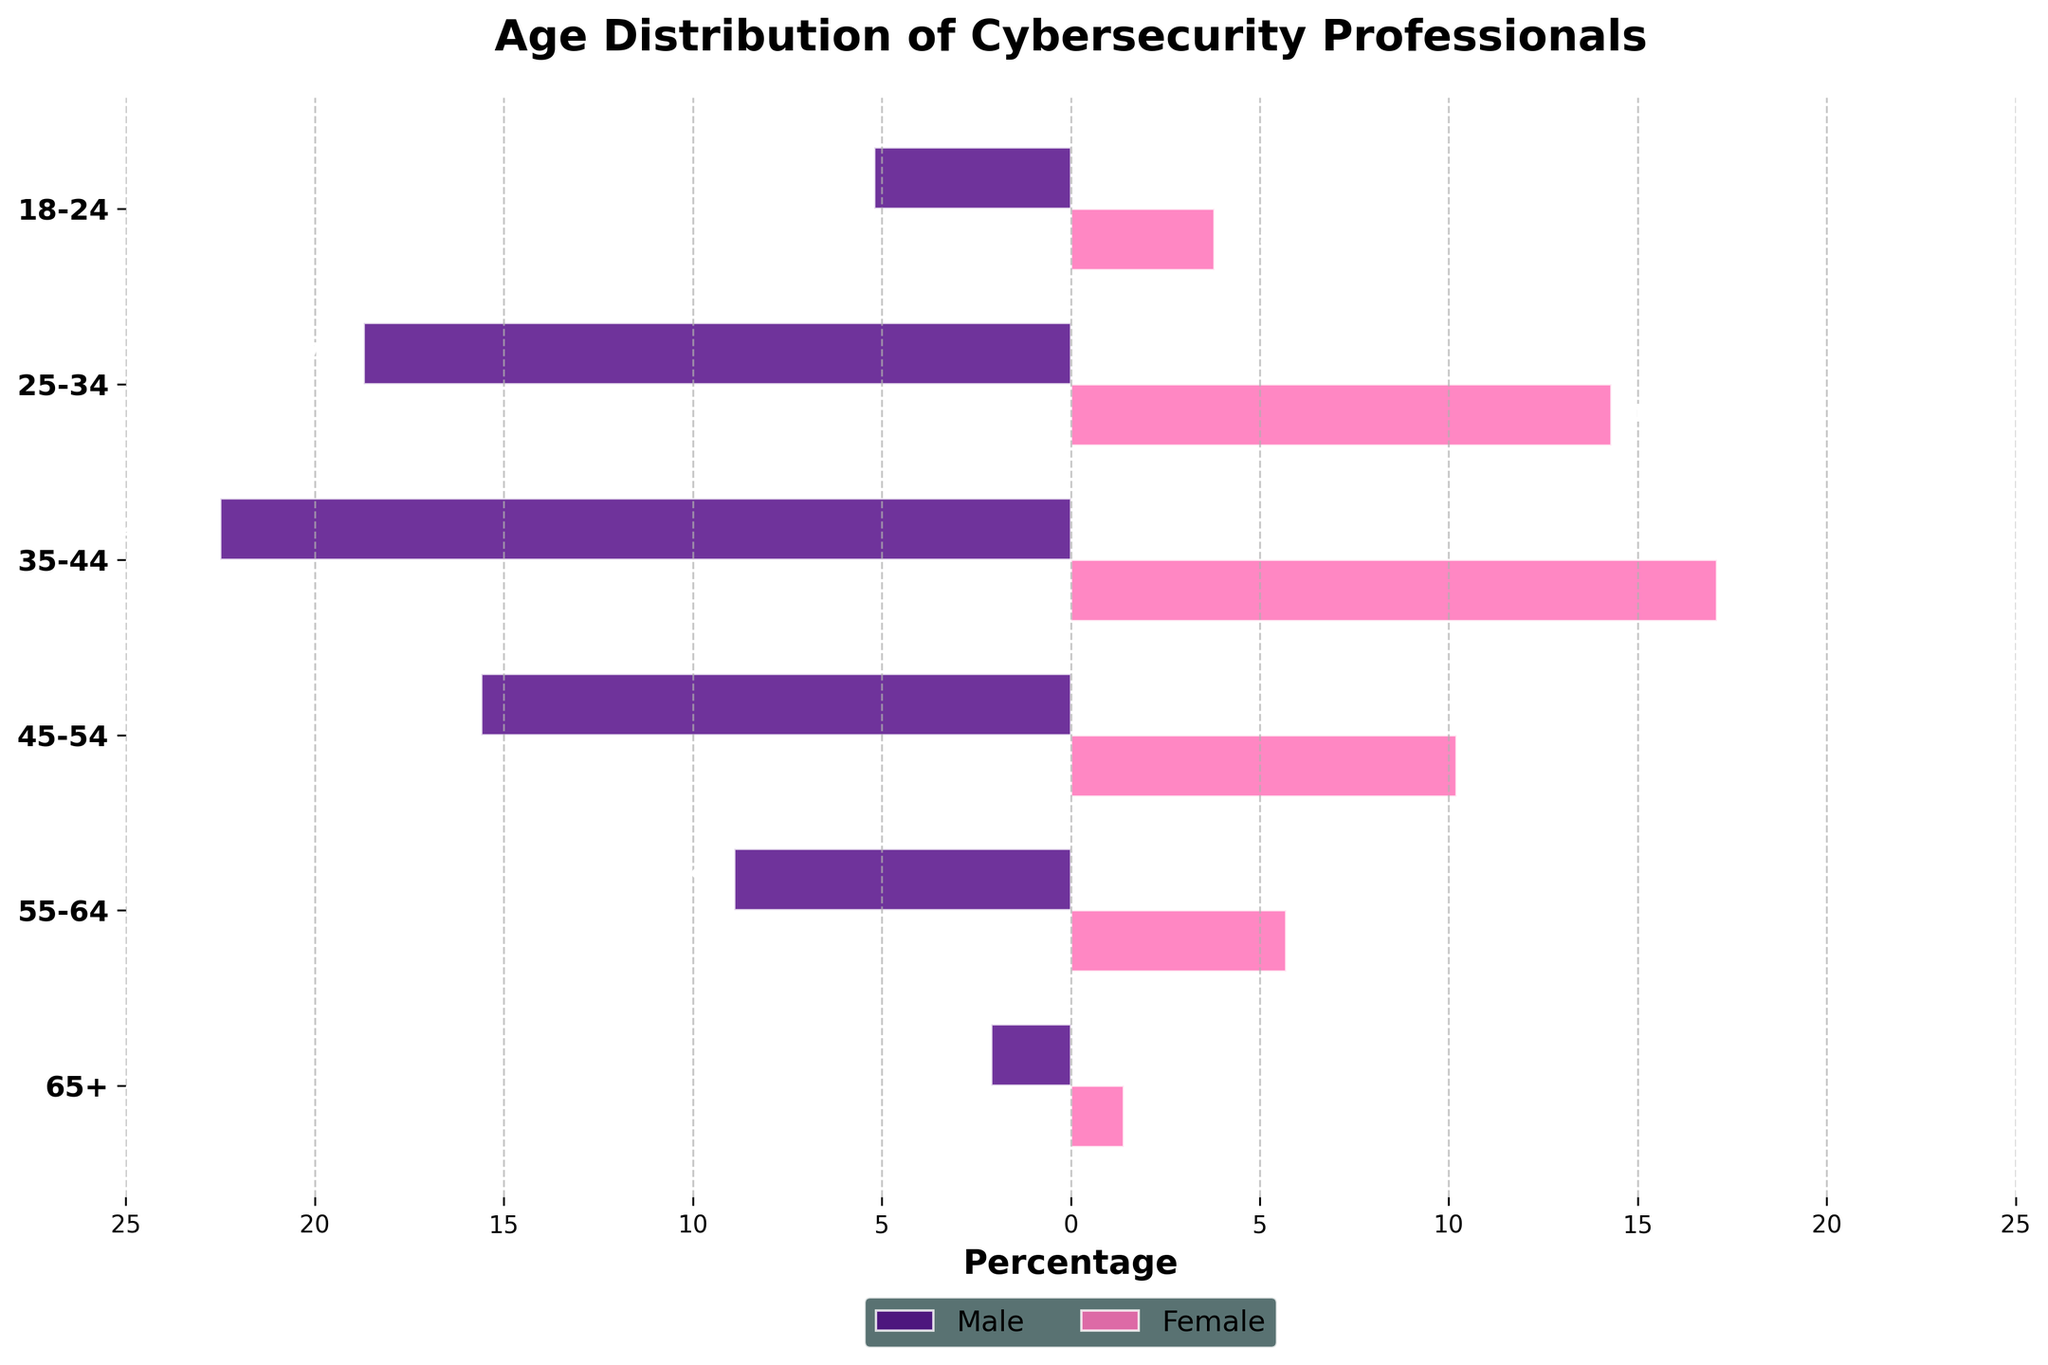What is the title of the figure? The title of the figure is usually placed at the top of the chart. In this case, it is explicitly stated in the plot design.
Answer: 'Age Distribution of Cybersecurity Professionals' What are the color codes used to represent male and female professionals? By observing the colors highlighted in the bars, we can identify Purple for males and Pink for females.
Answer: Males are in Purple; Females are in Pink Which age group has the largest percentage of male professionals? Looking at the lengths of the purple bars representing males, the age group 35-44 has the longest bar.
Answer: 35-44 age group Which age group has the smallest percentage of female professionals? By comparing the lengths of the pink bars across age groups, we see that the 65+ group has the shortest bar.
Answer: 65+ age group What is the percentage difference between males and females in the 25-34 age group? The values are 18.7% for males and 14.3% for females. The percentage difference is calculated as 18.7 - 14.3.
Answer: 4.4% What are the y-axis labels on the figure? The y-axis labels typically represent the age groups in population pyramids. In this case, they are explicitly listed from the data.
Answer: 18-24, 25-34, 35-44, 45-54, 55-64, 65+ Between which two adjacent age groups is the percentage of female professionals increasing the most? Comparing the differences between adjacent age groups: 18-24 to 25-34 (10.5%), 25-34 to 35-44 (2.8%), 35-44 to 45-54 (6.9%), 45-54 to 55-64 (4.5%), 55-64 to 65+ (0.7%), the largest increase is from 18-24 to 25-34.
Answer: 18-24 to 25-34 What is the total percentage of male professionals across all age groups? Summing up the percentages for males: 5.2 + 18.7 + 22.5 + 15.6 + 8.9 + 2.1 gives the total.
Answer: 73.0% Which age group has the closest male-to-female percentage ratio? Comparing the male and female percentages in each age group: 18-24 (5.2, 3.8), 25-34 (18.7, 14.3), 35-44 (22.5, 17.1), 45-54 (15.6, 10.2), 55-64 (8.9, 5.7), 65+ (2.1, 1.4). Calculating the differences, the smallest difference is in the 65+ age group.
Answer: 65+ age group In which age group is the generational gap between male and female professionals most prominent? The generational gap can be observed by comparing the differences in percentages. The largest difference is noted in the 35-44 age group with a difference of 5.4%.
Answer: 35-44 age group 